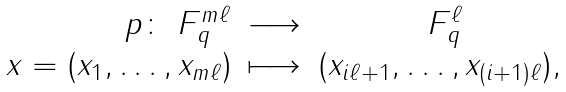Convert formula to latex. <formula><loc_0><loc_0><loc_500><loc_500>\begin{array} { r l c } p \colon \ F _ { q } ^ { m \ell } & \longrightarrow & \ F _ { q } ^ { \ell } \\ x = ( x _ { 1 } , \dots , x _ { m \ell } ) & \longmapsto & ( x _ { i \ell + 1 } , \dots , x _ { ( i + 1 ) \ell } ) , \end{array}</formula> 